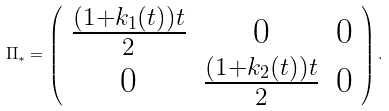<formula> <loc_0><loc_0><loc_500><loc_500>\Pi _ { * } = \left ( \begin{array} { c c c } \frac { ( 1 + k _ { 1 } ( t ) ) t } { 2 } & 0 & 0 \\ 0 & \frac { ( 1 + k _ { 2 } ( t ) ) t } { 2 } & 0 \end{array} \right ) .</formula> 